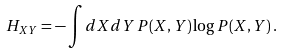Convert formula to latex. <formula><loc_0><loc_0><loc_500><loc_500>H _ { X Y } = - \int d X d Y \, P ( X , Y ) \log P ( X , Y ) \, .</formula> 